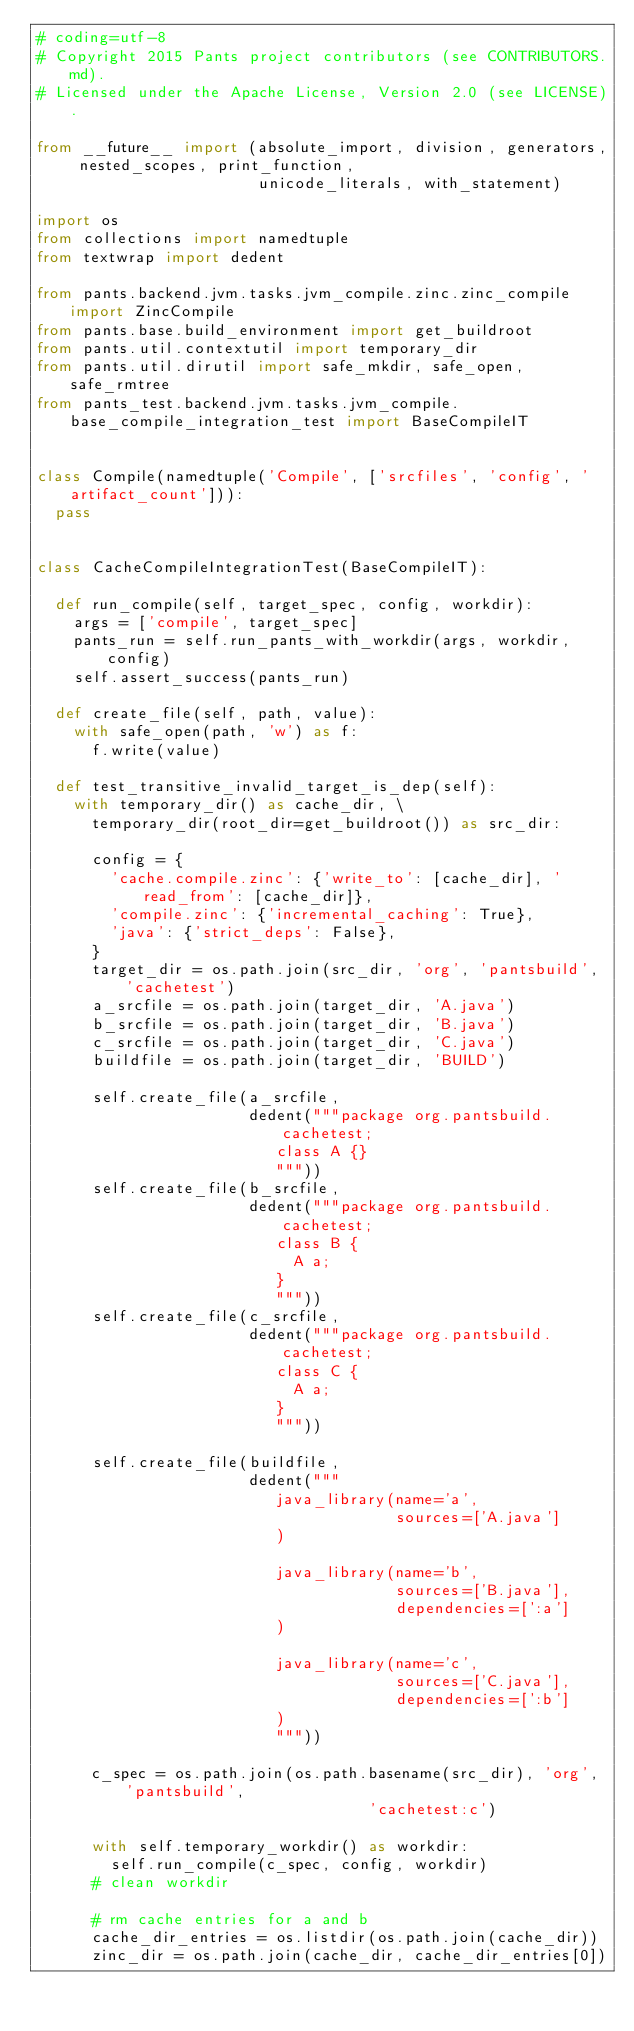Convert code to text. <code><loc_0><loc_0><loc_500><loc_500><_Python_># coding=utf-8
# Copyright 2015 Pants project contributors (see CONTRIBUTORS.md).
# Licensed under the Apache License, Version 2.0 (see LICENSE).

from __future__ import (absolute_import, division, generators, nested_scopes, print_function,
                        unicode_literals, with_statement)

import os
from collections import namedtuple
from textwrap import dedent

from pants.backend.jvm.tasks.jvm_compile.zinc.zinc_compile import ZincCompile
from pants.base.build_environment import get_buildroot
from pants.util.contextutil import temporary_dir
from pants.util.dirutil import safe_mkdir, safe_open, safe_rmtree
from pants_test.backend.jvm.tasks.jvm_compile.base_compile_integration_test import BaseCompileIT


class Compile(namedtuple('Compile', ['srcfiles', 'config', 'artifact_count'])):
  pass


class CacheCompileIntegrationTest(BaseCompileIT):

  def run_compile(self, target_spec, config, workdir):
    args = ['compile', target_spec]
    pants_run = self.run_pants_with_workdir(args, workdir, config)
    self.assert_success(pants_run)

  def create_file(self, path, value):
    with safe_open(path, 'w') as f:
      f.write(value)

  def test_transitive_invalid_target_is_dep(self):
    with temporary_dir() as cache_dir, \
      temporary_dir(root_dir=get_buildroot()) as src_dir:

      config = {
        'cache.compile.zinc': {'write_to': [cache_dir], 'read_from': [cache_dir]},
        'compile.zinc': {'incremental_caching': True},
        'java': {'strict_deps': False},
      }
      target_dir = os.path.join(src_dir, 'org', 'pantsbuild', 'cachetest')
      a_srcfile = os.path.join(target_dir, 'A.java')
      b_srcfile = os.path.join(target_dir, 'B.java')
      c_srcfile = os.path.join(target_dir, 'C.java')
      buildfile = os.path.join(target_dir, 'BUILD')

      self.create_file(a_srcfile,
                       dedent("""package org.pantsbuild.cachetest;
                          class A {}
                          """))
      self.create_file(b_srcfile,
                       dedent("""package org.pantsbuild.cachetest;
                          class B {
                            A a;
                          }
                          """))
      self.create_file(c_srcfile,
                       dedent("""package org.pantsbuild.cachetest;
                          class C {
                            A a;
                          }
                          """))

      self.create_file(buildfile,
                       dedent("""
                          java_library(name='a',
                                       sources=['A.java']
                          )

                          java_library(name='b',
                                       sources=['B.java'],
                                       dependencies=[':a']
                          )

                          java_library(name='c',
                                       sources=['C.java'],
                                       dependencies=[':b']
                          )
                          """))

      c_spec = os.path.join(os.path.basename(src_dir), 'org', 'pantsbuild',
                                    'cachetest:c')

      with self.temporary_workdir() as workdir:
        self.run_compile(c_spec, config, workdir)
      # clean workdir

      # rm cache entries for a and b
      cache_dir_entries = os.listdir(os.path.join(cache_dir))
      zinc_dir = os.path.join(cache_dir, cache_dir_entries[0])</code> 